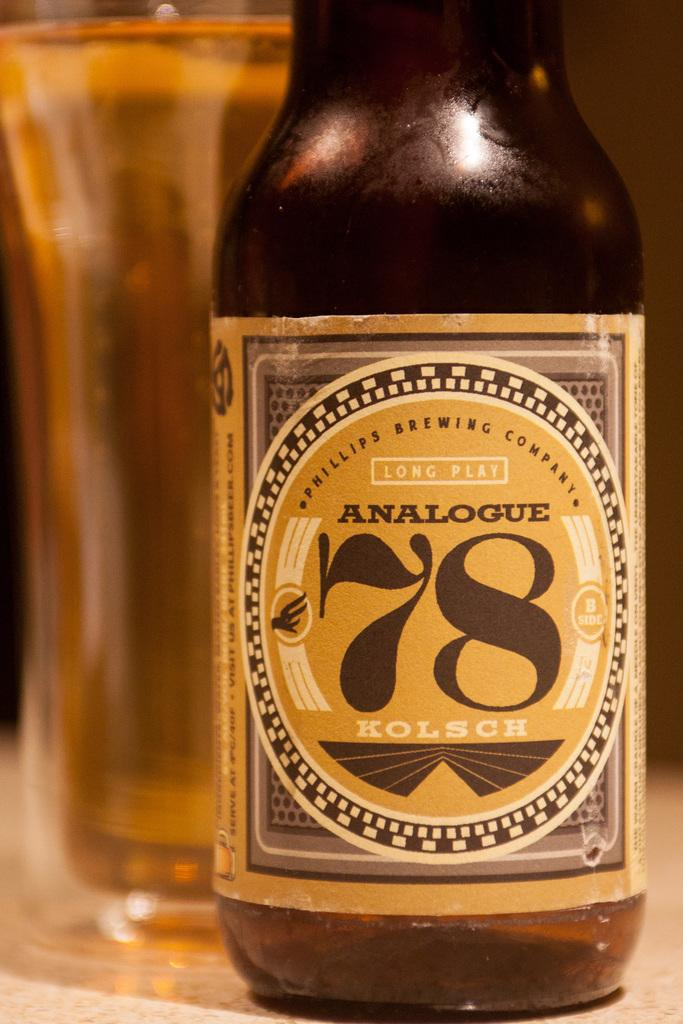<image>
Give a short and clear explanation of the subsequent image. The number 78 is on a label on a bottle. 